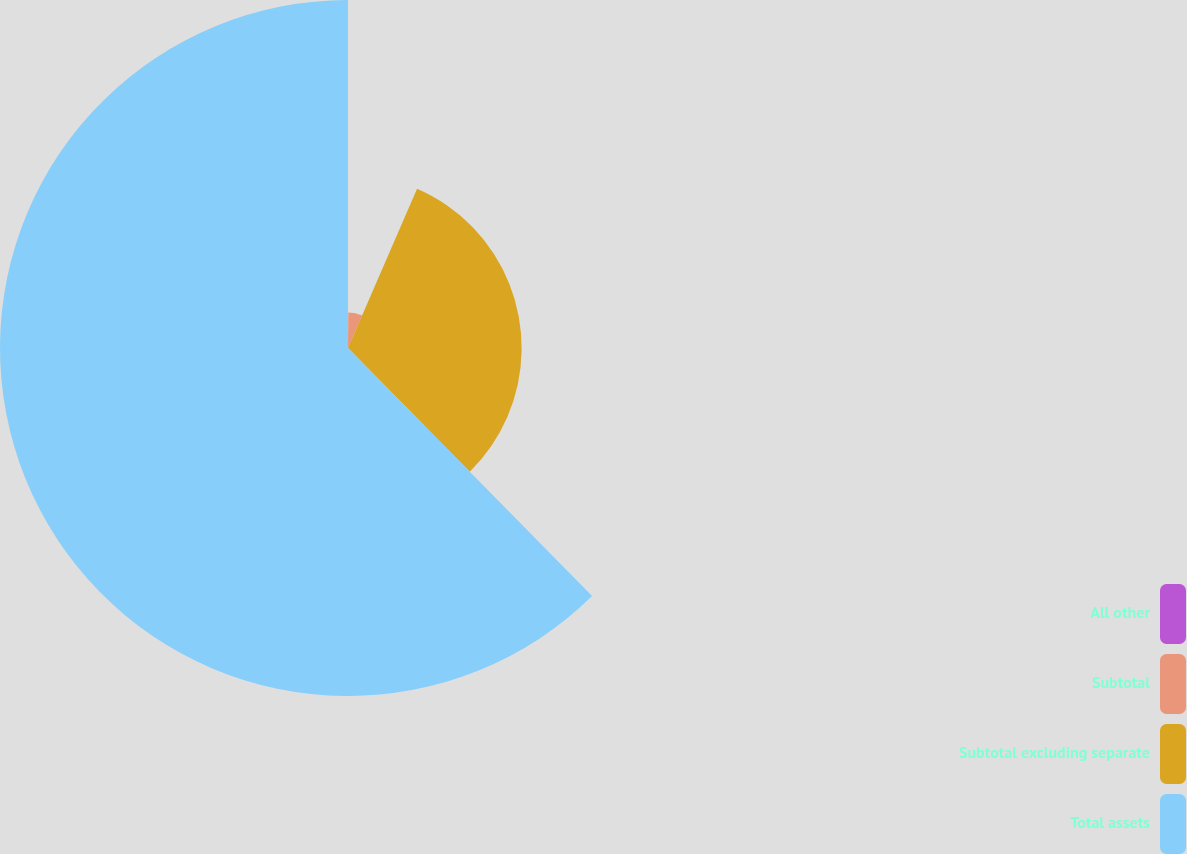<chart> <loc_0><loc_0><loc_500><loc_500><pie_chart><fcel>All other<fcel>Subtotal<fcel>Subtotal excluding separate<fcel>Total assets<nl><fcel>0.14%<fcel>6.37%<fcel>31.12%<fcel>62.37%<nl></chart> 